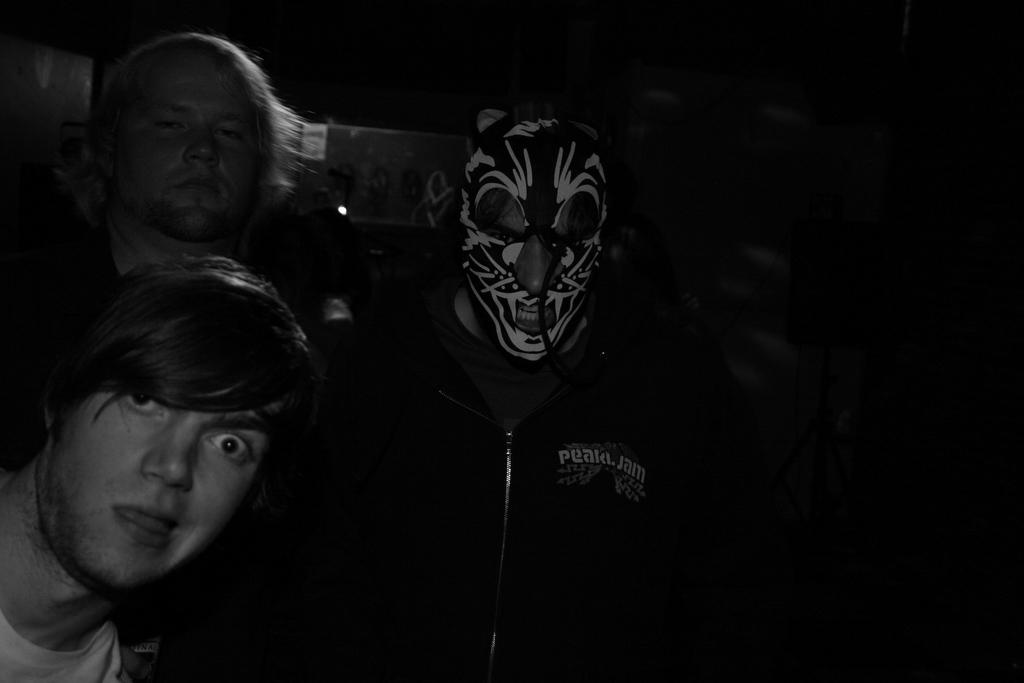How many people are present in the image? There are two people in the image. Can you describe one of the individuals in the image? There is a man wearing a mask in the image. What can be observed about the lighting or color of the background in the image? The background of the image is dark. What type of vase is placed on the table during the meal in the image? There is no table, meal, or vase present in the image. What flavor of soda is being consumed by the people in the image? There is no soda or consumption of any beverage depicted in the image. 